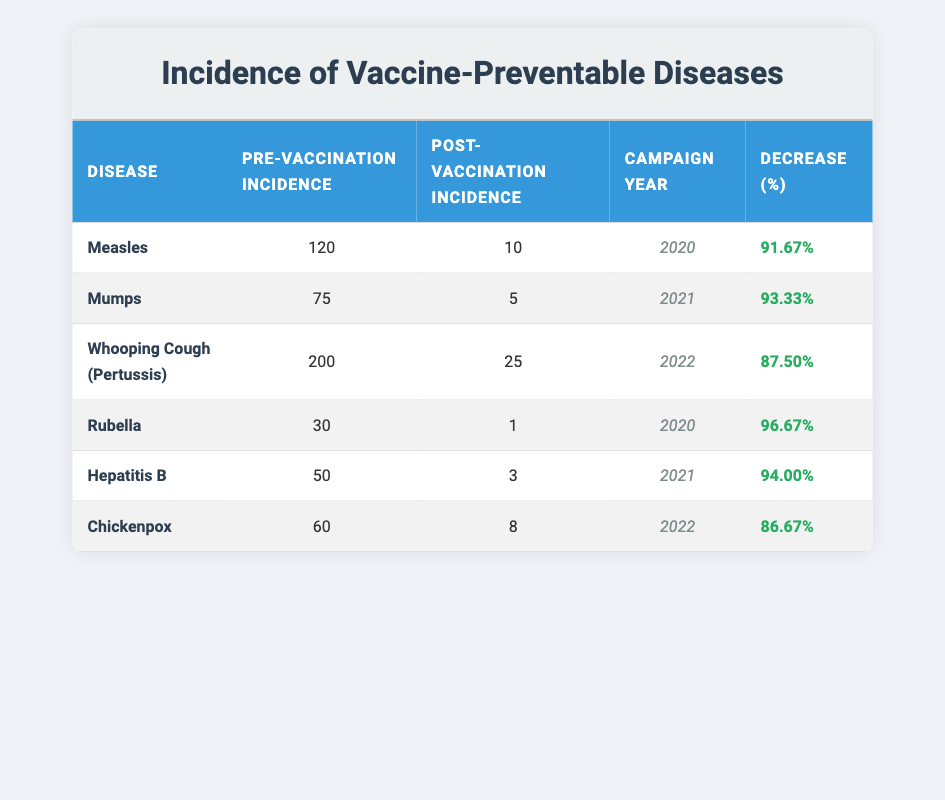What was the post-vaccination incidence of Measles? According to the table, the post-vaccination incidence for Measles is listed as 10.
Answer: 10 What percentage decrease in incidence was observed for Mumps after the vaccination campaign? The pre-vaccination incidence for Mumps was 75, and the post-vaccination incidence was 5. The decrease can be calculated as ((75 - 5) / 75) * 100 = 93.33%.
Answer: 93.33% Is it true that the post-vaccination incidence for Hepatitis B is lower than that for Whooping Cough? The post-vaccination incidence for Hepatitis B is 3, while for Whooping Cough it is 25. Since 3 is less than 25, the statement is true.
Answer: Yes Which disease had the highest percentage decrease in incidence after vaccination? The diseases with their percentage decrements are: Measles (91.67%), Mumps (93.33%), Whooping Cough (87.50%), Rubella (96.67%), Hepatitis B (94.00%), and Chickenpox (86.67%). Among these, Rubella has the highest decrease at 96.67%.
Answer: Rubella What is the average pre-vaccination incidence across all diseases listed in the table? To find the average pre-vaccination incidence, add all the pre-vaccination incidences: 120 + 75 + 200 + 30 + 50 + 60 = 535. Then, divide by the number of diseases, which is 6. So, 535 / 6 = 89.17.
Answer: 89.17 